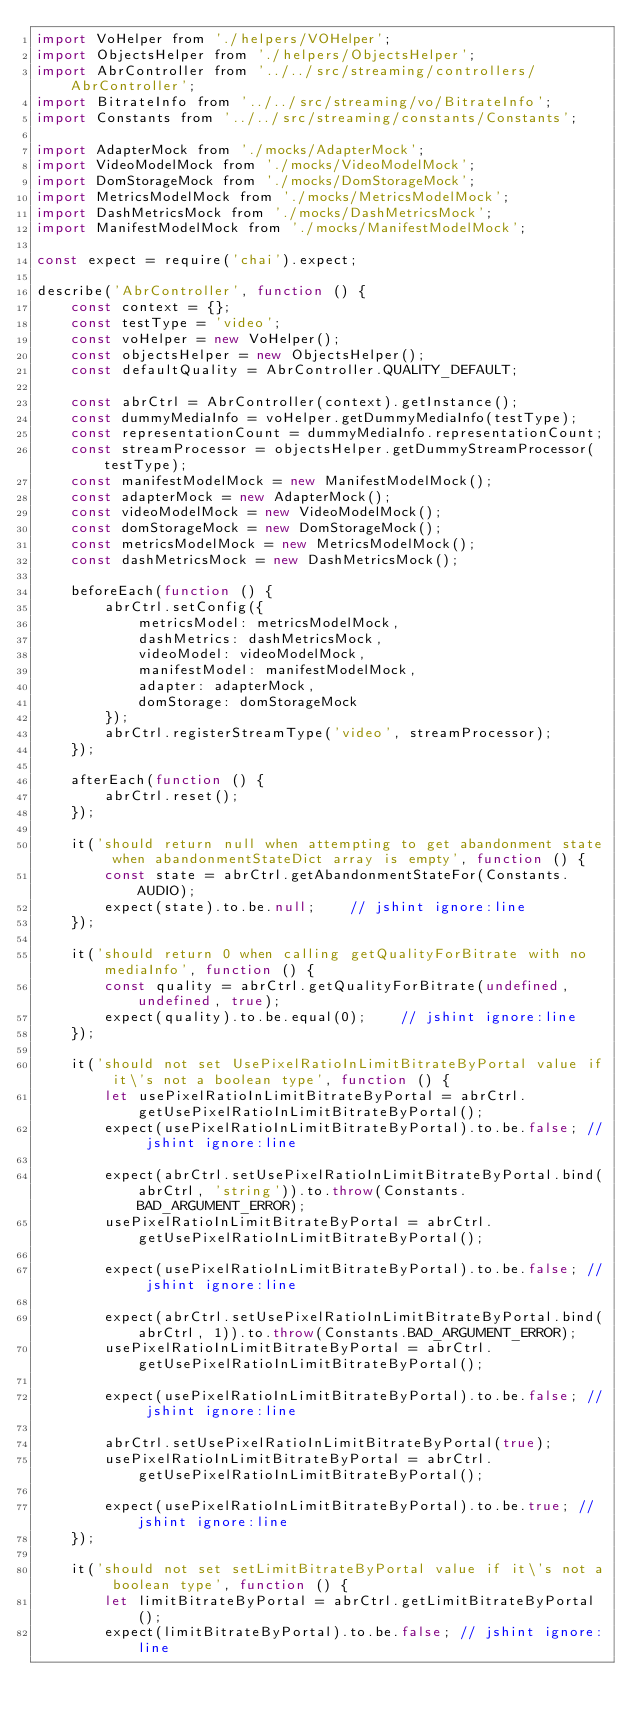<code> <loc_0><loc_0><loc_500><loc_500><_JavaScript_>import VoHelper from './helpers/VOHelper';
import ObjectsHelper from './helpers/ObjectsHelper';
import AbrController from '../../src/streaming/controllers/AbrController';
import BitrateInfo from '../../src/streaming/vo/BitrateInfo';
import Constants from '../../src/streaming/constants/Constants';

import AdapterMock from './mocks/AdapterMock';
import VideoModelMock from './mocks/VideoModelMock';
import DomStorageMock from './mocks/DomStorageMock';
import MetricsModelMock from './mocks/MetricsModelMock';
import DashMetricsMock from './mocks/DashMetricsMock';
import ManifestModelMock from './mocks/ManifestModelMock';

const expect = require('chai').expect;

describe('AbrController', function () {
    const context = {};
    const testType = 'video';
    const voHelper = new VoHelper();
    const objectsHelper = new ObjectsHelper();
    const defaultQuality = AbrController.QUALITY_DEFAULT;

    const abrCtrl = AbrController(context).getInstance();
    const dummyMediaInfo = voHelper.getDummyMediaInfo(testType);
    const representationCount = dummyMediaInfo.representationCount;
    const streamProcessor = objectsHelper.getDummyStreamProcessor(testType);
    const manifestModelMock = new ManifestModelMock();
    const adapterMock = new AdapterMock();
    const videoModelMock = new VideoModelMock();
    const domStorageMock = new DomStorageMock();
    const metricsModelMock = new MetricsModelMock();
    const dashMetricsMock = new DashMetricsMock();

    beforeEach(function () {
        abrCtrl.setConfig({
            metricsModel: metricsModelMock,
            dashMetrics: dashMetricsMock,
            videoModel: videoModelMock,
            manifestModel: manifestModelMock,
            adapter: adapterMock,
            domStorage: domStorageMock
        });
        abrCtrl.registerStreamType('video', streamProcessor);
    });

    afterEach(function () {
        abrCtrl.reset();
    });

    it('should return null when attempting to get abandonment state when abandonmentStateDict array is empty', function () {
        const state = abrCtrl.getAbandonmentStateFor(Constants.AUDIO);
        expect(state).to.be.null;    // jshint ignore:line
    });

    it('should return 0 when calling getQualityForBitrate with no mediaInfo', function () {
        const quality = abrCtrl.getQualityForBitrate(undefined, undefined, true);
        expect(quality).to.be.equal(0);    // jshint ignore:line
    });

    it('should not set UsePixelRatioInLimitBitrateByPortal value if it\'s not a boolean type', function () {
        let usePixelRatioInLimitBitrateByPortal = abrCtrl.getUsePixelRatioInLimitBitrateByPortal();
        expect(usePixelRatioInLimitBitrateByPortal).to.be.false; // jshint ignore:line

        expect(abrCtrl.setUsePixelRatioInLimitBitrateByPortal.bind(abrCtrl, 'string')).to.throw(Constants.BAD_ARGUMENT_ERROR);
        usePixelRatioInLimitBitrateByPortal = abrCtrl.getUsePixelRatioInLimitBitrateByPortal();

        expect(usePixelRatioInLimitBitrateByPortal).to.be.false; // jshint ignore:line

        expect(abrCtrl.setUsePixelRatioInLimitBitrateByPortal.bind(abrCtrl, 1)).to.throw(Constants.BAD_ARGUMENT_ERROR);
        usePixelRatioInLimitBitrateByPortal = abrCtrl.getUsePixelRatioInLimitBitrateByPortal();

        expect(usePixelRatioInLimitBitrateByPortal).to.be.false; // jshint ignore:line

        abrCtrl.setUsePixelRatioInLimitBitrateByPortal(true);
        usePixelRatioInLimitBitrateByPortal = abrCtrl.getUsePixelRatioInLimitBitrateByPortal();

        expect(usePixelRatioInLimitBitrateByPortal).to.be.true; // jshint ignore:line
    });

    it('should not set setLimitBitrateByPortal value if it\'s not a boolean type', function () {
        let limitBitrateByPortal = abrCtrl.getLimitBitrateByPortal();
        expect(limitBitrateByPortal).to.be.false; // jshint ignore:line
</code> 